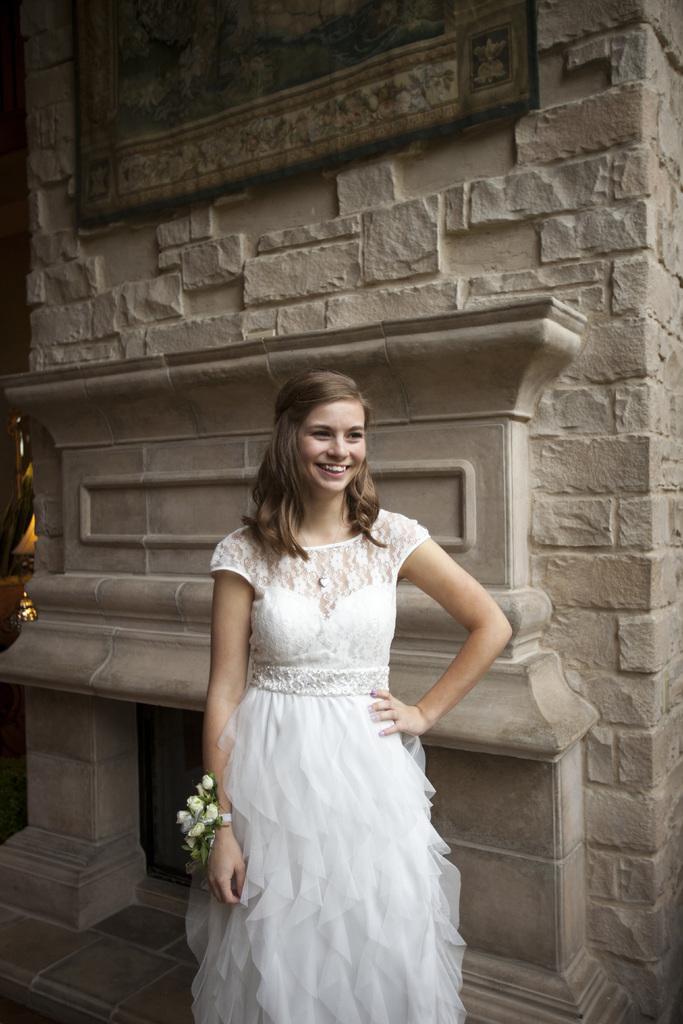Please provide a concise description of this image. In this image there is a girl in white dress with flower bracelet is standing in front of wall and posing for a photo. 